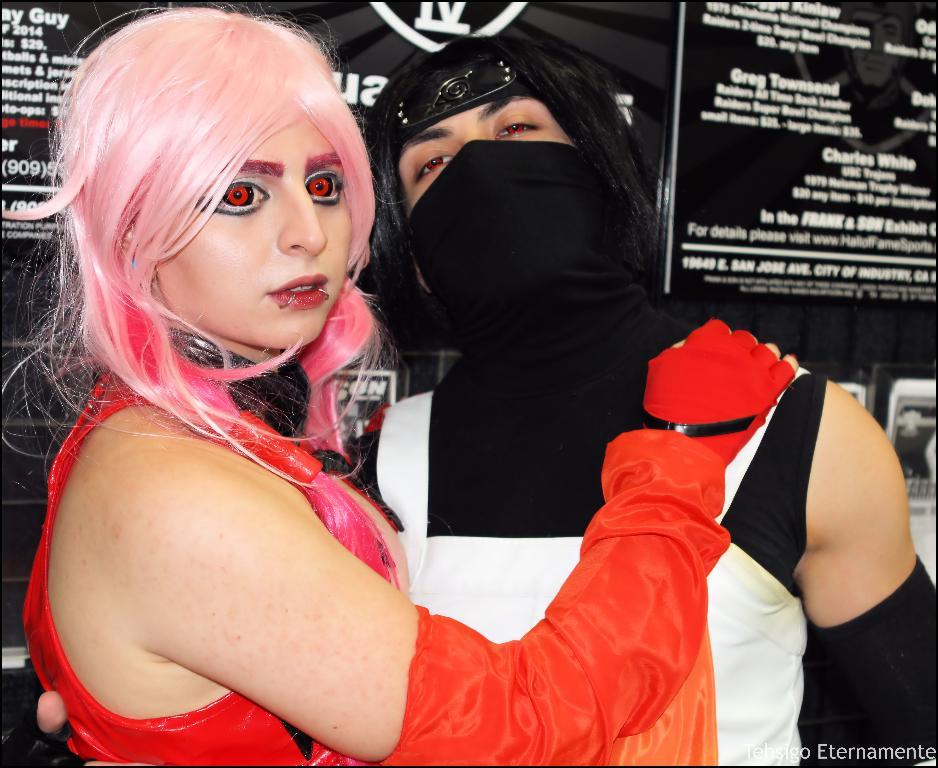<image>
Share a concise interpretation of the image provided. Behind a cosplayer are signs with information about Charles White and others. 